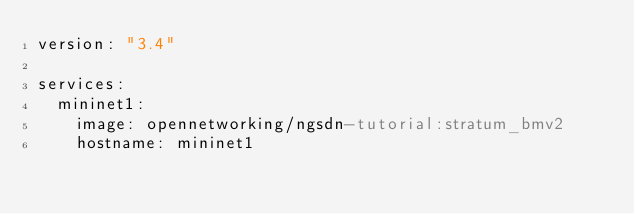<code> <loc_0><loc_0><loc_500><loc_500><_YAML_>version: "3.4"

services:
  mininet1:
    image: opennetworking/ngsdn-tutorial:stratum_bmv2
    hostname: mininet1</code> 